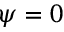Convert formula to latex. <formula><loc_0><loc_0><loc_500><loc_500>\psi = 0</formula> 